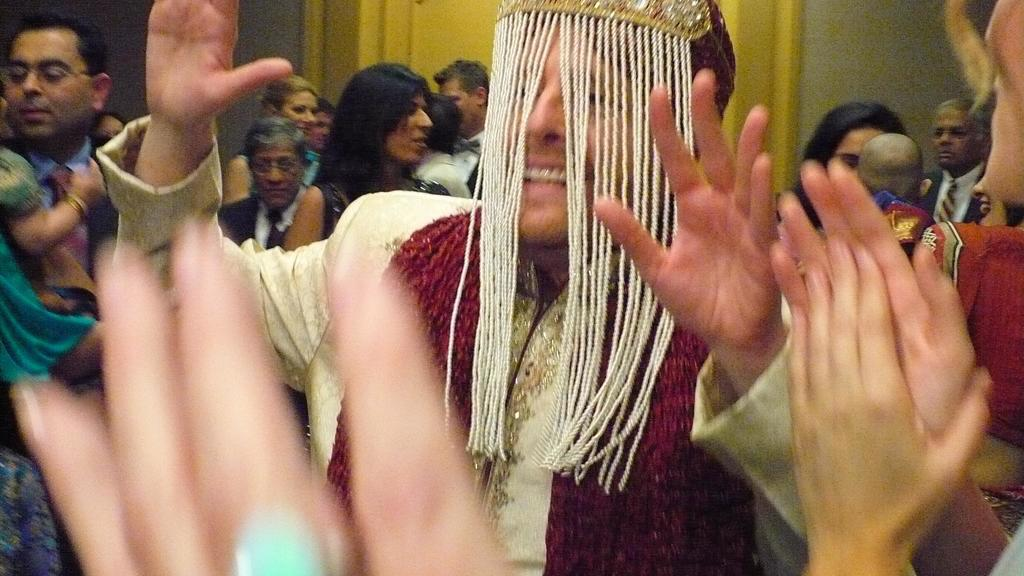How many people are in the image? There is a group of people in the image, but the exact number cannot be determined from the provided facts. What is behind the people in the image? There is a wall behind the people in the image. Can you describe any features of the wall? There appears to be a door in the wall. What type of drug can be seen in the hands of the people in the image? There is no mention of any drugs in the image, so it is not possible to answer that question. 